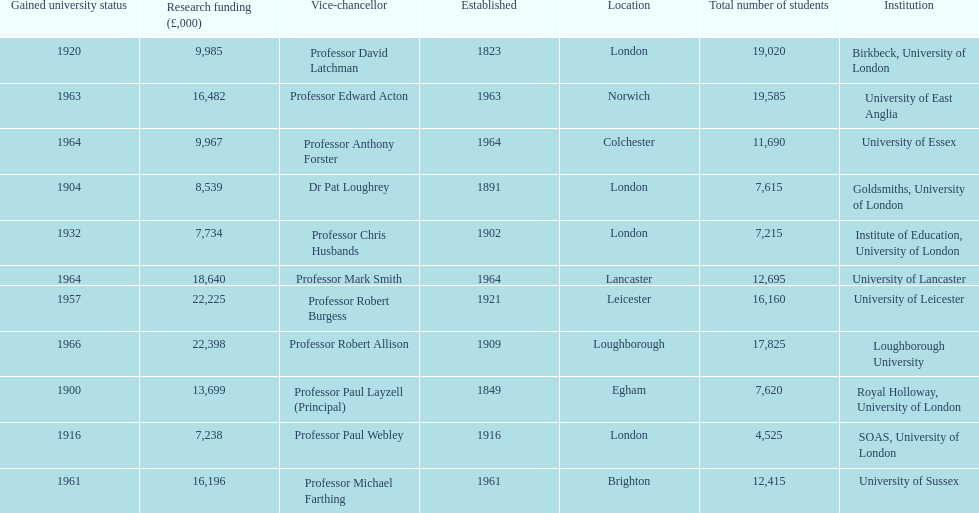How many of the institutions are located in london? 4. 